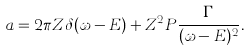<formula> <loc_0><loc_0><loc_500><loc_500>a = 2 \pi Z \delta ( \omega - E ) + Z ^ { 2 } P \frac { \Gamma } { ( \omega - E ) ^ { 2 } } .</formula> 